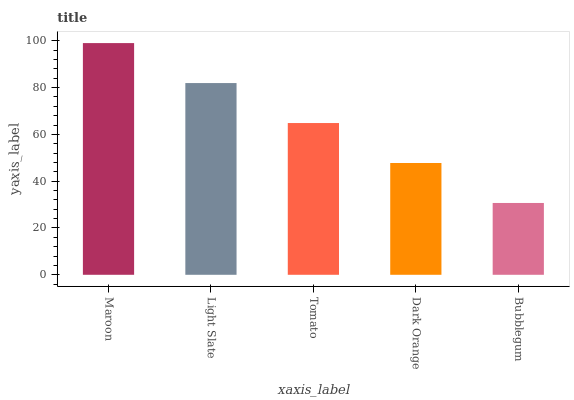Is Bubblegum the minimum?
Answer yes or no. Yes. Is Maroon the maximum?
Answer yes or no. Yes. Is Light Slate the minimum?
Answer yes or no. No. Is Light Slate the maximum?
Answer yes or no. No. Is Maroon greater than Light Slate?
Answer yes or no. Yes. Is Light Slate less than Maroon?
Answer yes or no. Yes. Is Light Slate greater than Maroon?
Answer yes or no. No. Is Maroon less than Light Slate?
Answer yes or no. No. Is Tomato the high median?
Answer yes or no. Yes. Is Tomato the low median?
Answer yes or no. Yes. Is Light Slate the high median?
Answer yes or no. No. Is Maroon the low median?
Answer yes or no. No. 